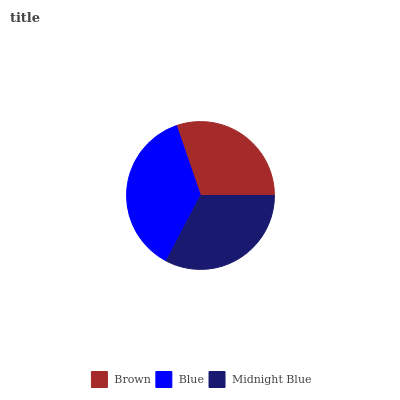Is Brown the minimum?
Answer yes or no. Yes. Is Blue the maximum?
Answer yes or no. Yes. Is Midnight Blue the minimum?
Answer yes or no. No. Is Midnight Blue the maximum?
Answer yes or no. No. Is Blue greater than Midnight Blue?
Answer yes or no. Yes. Is Midnight Blue less than Blue?
Answer yes or no. Yes. Is Midnight Blue greater than Blue?
Answer yes or no. No. Is Blue less than Midnight Blue?
Answer yes or no. No. Is Midnight Blue the high median?
Answer yes or no. Yes. Is Midnight Blue the low median?
Answer yes or no. Yes. Is Brown the high median?
Answer yes or no. No. Is Blue the low median?
Answer yes or no. No. 